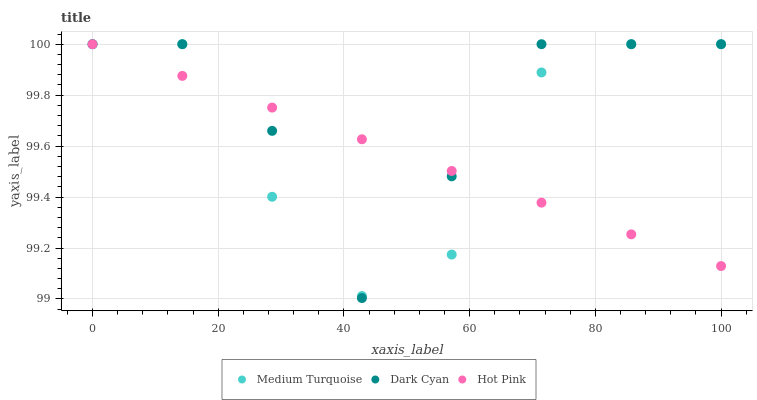Does Hot Pink have the minimum area under the curve?
Answer yes or no. Yes. Does Dark Cyan have the maximum area under the curve?
Answer yes or no. Yes. Does Medium Turquoise have the minimum area under the curve?
Answer yes or no. No. Does Medium Turquoise have the maximum area under the curve?
Answer yes or no. No. Is Hot Pink the smoothest?
Answer yes or no. Yes. Is Medium Turquoise the roughest?
Answer yes or no. Yes. Is Medium Turquoise the smoothest?
Answer yes or no. No. Is Hot Pink the roughest?
Answer yes or no. No. Does Dark Cyan have the lowest value?
Answer yes or no. Yes. Does Medium Turquoise have the lowest value?
Answer yes or no. No. Does Medium Turquoise have the highest value?
Answer yes or no. Yes. Does Hot Pink intersect Medium Turquoise?
Answer yes or no. Yes. Is Hot Pink less than Medium Turquoise?
Answer yes or no. No. Is Hot Pink greater than Medium Turquoise?
Answer yes or no. No. 